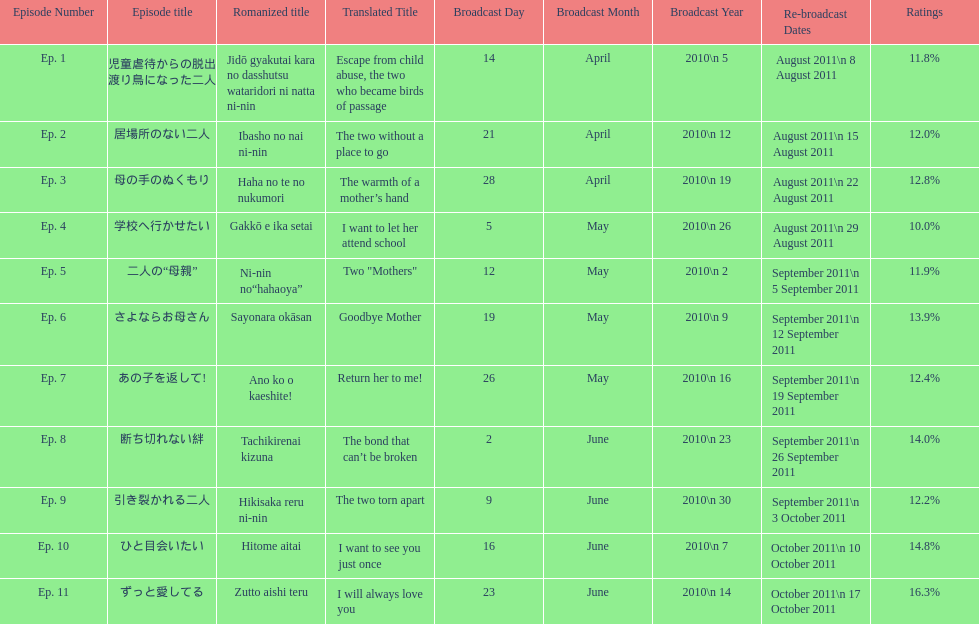How many episode are not over 14%? 8. 